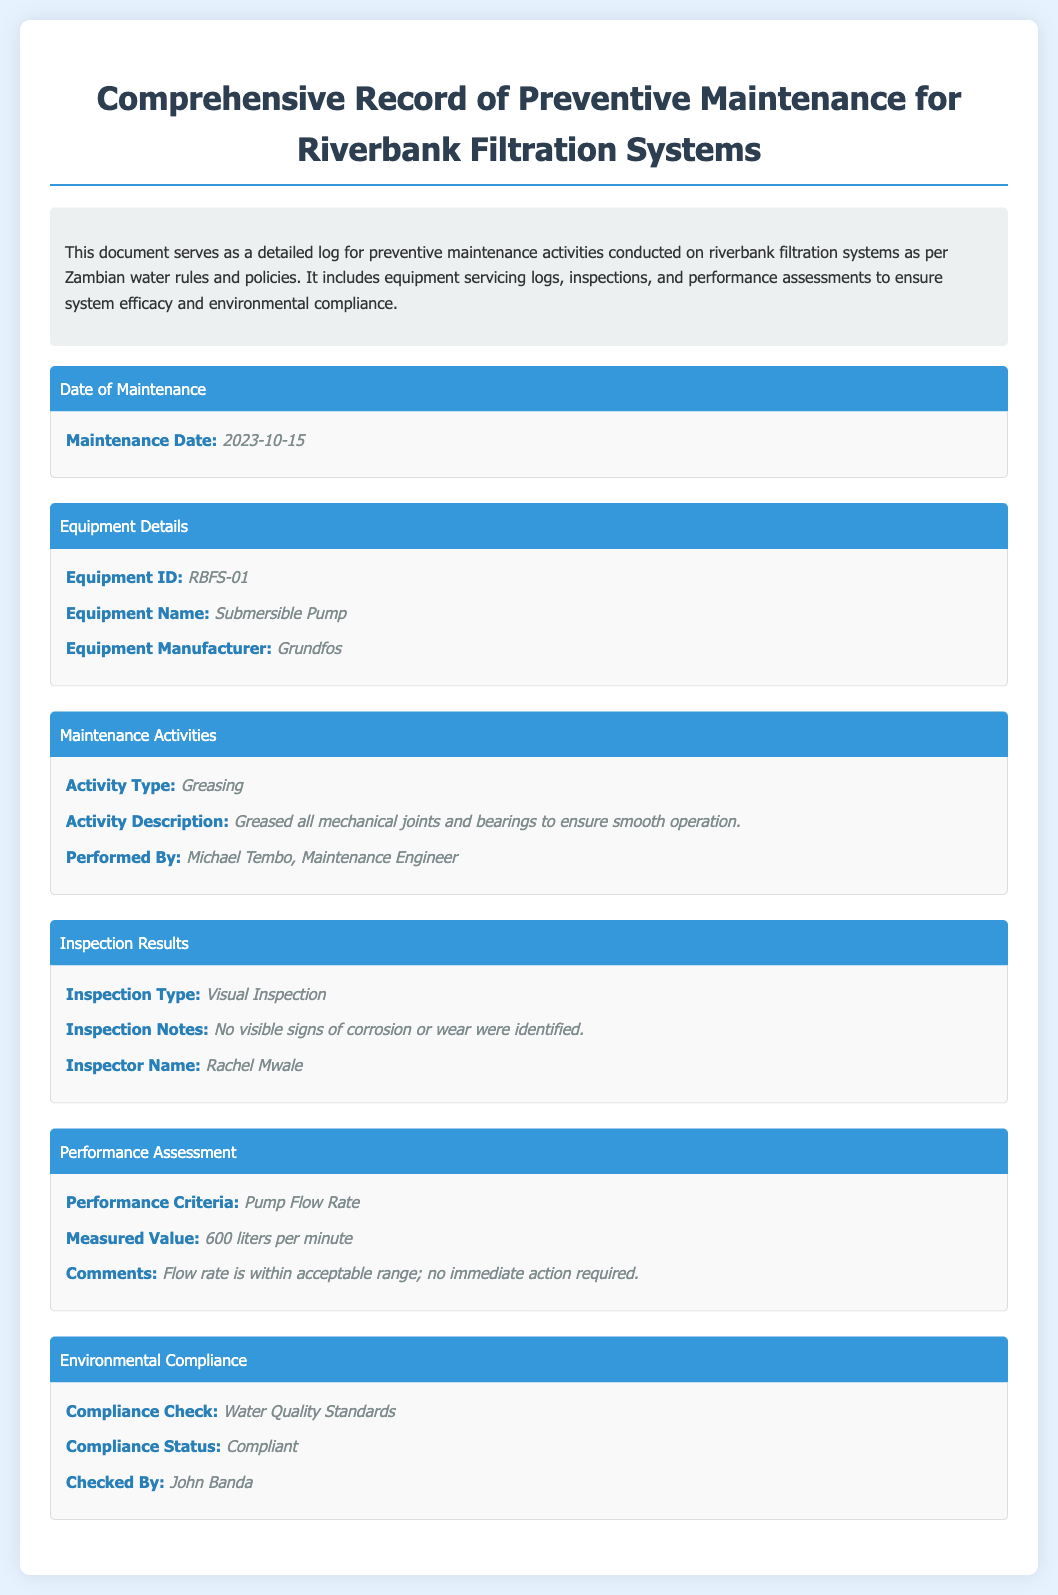What is the date of maintenance? The date of maintenance is listed in the maintenance log under the section "Date of Maintenance."
Answer: 2023-10-15 What is the Equipment ID? The Equipment ID is specified in the "Equipment Details" section of the document.
Answer: RBFS-01 Who performed the maintenance activity? The name of the person who performed the maintenance is given in the "Maintenance Activities" section.
Answer: Michael Tembo, Maintenance Engineer What type of inspection was conducted? The type of inspection can be found in the "Inspection Results" section of the log.
Answer: Visual Inspection What was the measured flow rate? The measured value of the pump flow rate is noted in the "Performance Assessment" section.
Answer: 600 liters per minute What is the compliance status? The compliance status with respect to environmental regulations is detailed in the "Environmental Compliance" section.
Answer: Compliant What was the activity type performed? The activity type is listed in the "Maintenance Activities" section of the document.
Answer: Greasing Who checked the environmental compliance? The name of the person who checked the compliance is mentioned in the "Environmental Compliance" section.
Answer: John Banda 